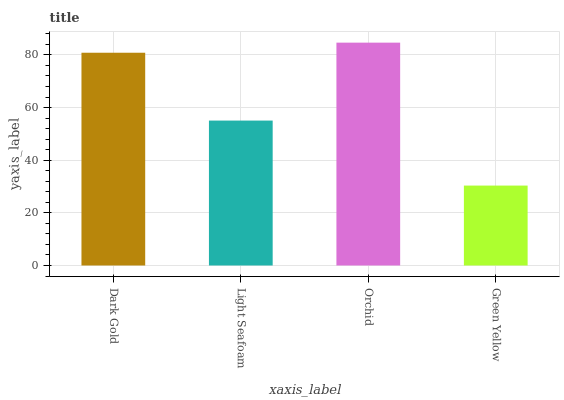Is Green Yellow the minimum?
Answer yes or no. Yes. Is Orchid the maximum?
Answer yes or no. Yes. Is Light Seafoam the minimum?
Answer yes or no. No. Is Light Seafoam the maximum?
Answer yes or no. No. Is Dark Gold greater than Light Seafoam?
Answer yes or no. Yes. Is Light Seafoam less than Dark Gold?
Answer yes or no. Yes. Is Light Seafoam greater than Dark Gold?
Answer yes or no. No. Is Dark Gold less than Light Seafoam?
Answer yes or no. No. Is Dark Gold the high median?
Answer yes or no. Yes. Is Light Seafoam the low median?
Answer yes or no. Yes. Is Orchid the high median?
Answer yes or no. No. Is Green Yellow the low median?
Answer yes or no. No. 